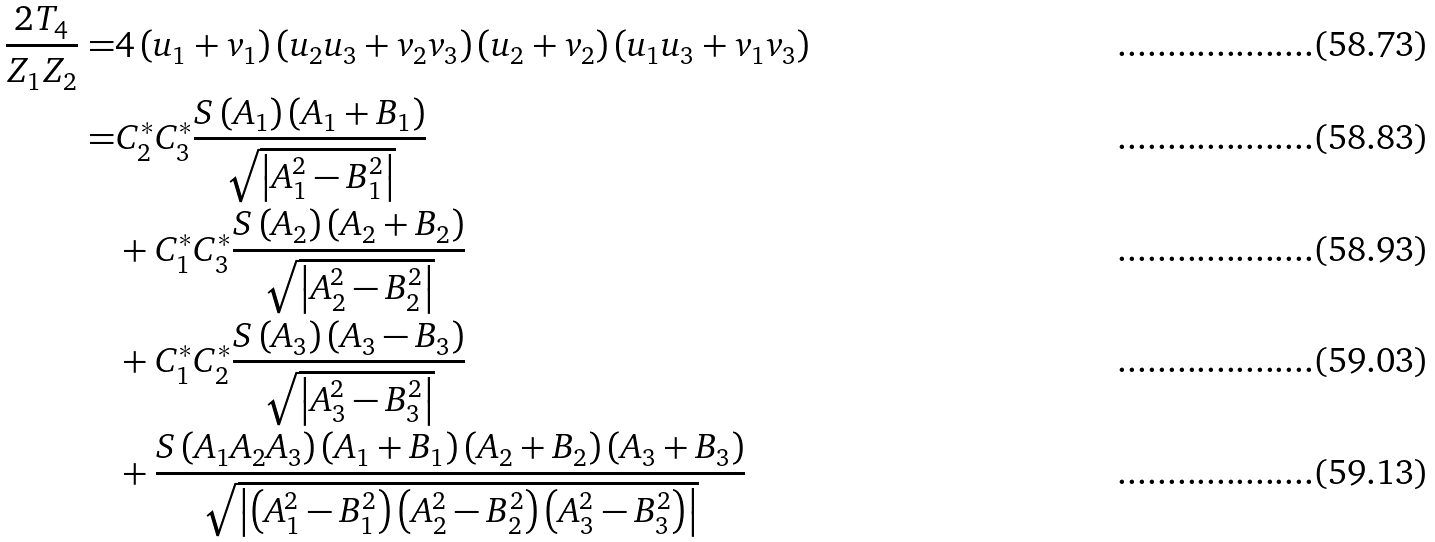Convert formula to latex. <formula><loc_0><loc_0><loc_500><loc_500>\frac { 2 T _ { 4 } } { Z _ { 1 } Z _ { 2 } } = & 4 \left ( u _ { 1 } + v _ { 1 } \right ) \left ( u _ { 2 } u _ { 3 } + v _ { 2 } v _ { 3 } \right ) \left ( u _ { 2 } + v _ { 2 } \right ) \left ( u _ { 1 } u _ { 3 } + v _ { 1 } v _ { 3 } \right ) \\ = & C _ { 2 } ^ { * } C _ { 3 } ^ { * } \frac { S \left ( A _ { 1 } \right ) \left ( A _ { 1 } + B _ { 1 } \right ) } { \sqrt { \left | A _ { 1 } ^ { 2 } - B _ { 1 } ^ { 2 } \right | } } \\ & + C _ { 1 } ^ { * } C _ { 3 } ^ { * } \frac { S \left ( A _ { 2 } \right ) \left ( A _ { 2 } + B _ { 2 } \right ) } { \sqrt { \left | A _ { 2 } ^ { 2 } - B _ { 2 } ^ { 2 } \right | } } \\ & + C _ { 1 } ^ { * } C _ { 2 } ^ { * } \frac { S \left ( A _ { 3 } \right ) \left ( A _ { 3 } - B _ { 3 } \right ) } { \sqrt { \left | A _ { 3 } ^ { 2 } - B _ { 3 } ^ { 2 } \right | } } \\ & + \frac { S \left ( A _ { 1 } A _ { 2 } A _ { 3 } \right ) \left ( A _ { 1 } + B _ { 1 } \right ) \left ( A _ { 2 } + B _ { 2 } \right ) \left ( A _ { 3 } + B _ { 3 } \right ) } { \sqrt { \left | \left ( A _ { 1 } ^ { 2 } - B _ { 1 } ^ { 2 } \right ) \left ( A _ { 2 } ^ { 2 } - B _ { 2 } ^ { 2 } \right ) \left ( A _ { 3 } ^ { 2 } - B _ { 3 } ^ { 2 } \right ) \right | } }</formula> 